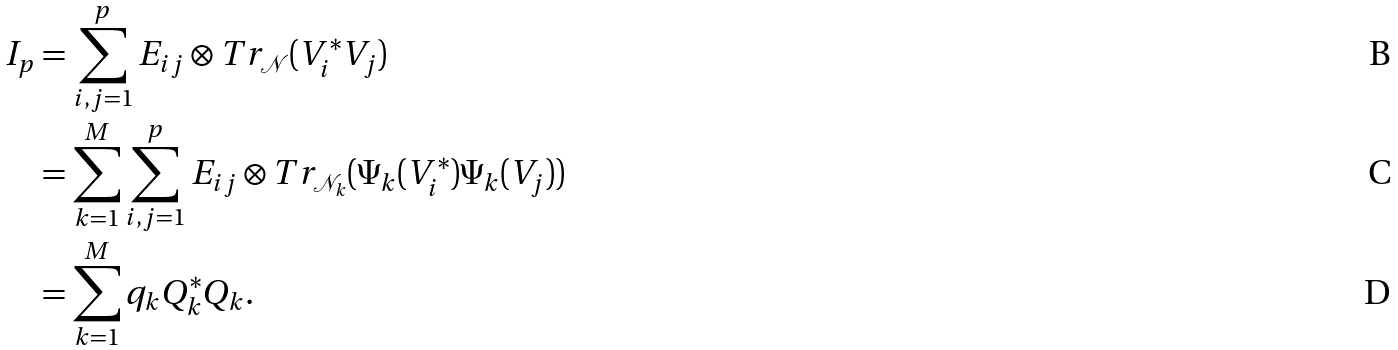Convert formula to latex. <formula><loc_0><loc_0><loc_500><loc_500>I _ { p } & = \sum _ { i , j = 1 } ^ { p } E _ { i j } \otimes T r _ { \mathcal { N } } ( V _ { i } ^ { * } V _ { j } ) \\ & = \sum _ { k = 1 } ^ { M } \sum _ { i , j = 1 } ^ { p } E _ { i j } \otimes T r _ { \mathcal { N } _ { k } } ( \Psi _ { k } ( V _ { i } ^ { * } ) \Psi _ { k } ( V _ { j } ) ) \\ & = \sum _ { k = 1 } ^ { M } q _ { k } Q _ { k } ^ { * } Q _ { k } .</formula> 